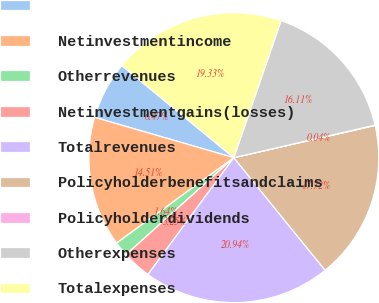Convert chart. <chart><loc_0><loc_0><loc_500><loc_500><pie_chart><ecel><fcel>Netinvestmentincome<fcel>Otherrevenues<fcel>Netinvestmentgains(losses)<fcel>Totalrevenues<fcel>Policyholderbenefitsandclaims<fcel>Policyholderdividends<fcel>Otherexpenses<fcel>Totalexpenses<nl><fcel>6.47%<fcel>14.51%<fcel>1.64%<fcel>3.25%<fcel>20.94%<fcel>17.72%<fcel>0.04%<fcel>16.11%<fcel>19.33%<nl></chart> 